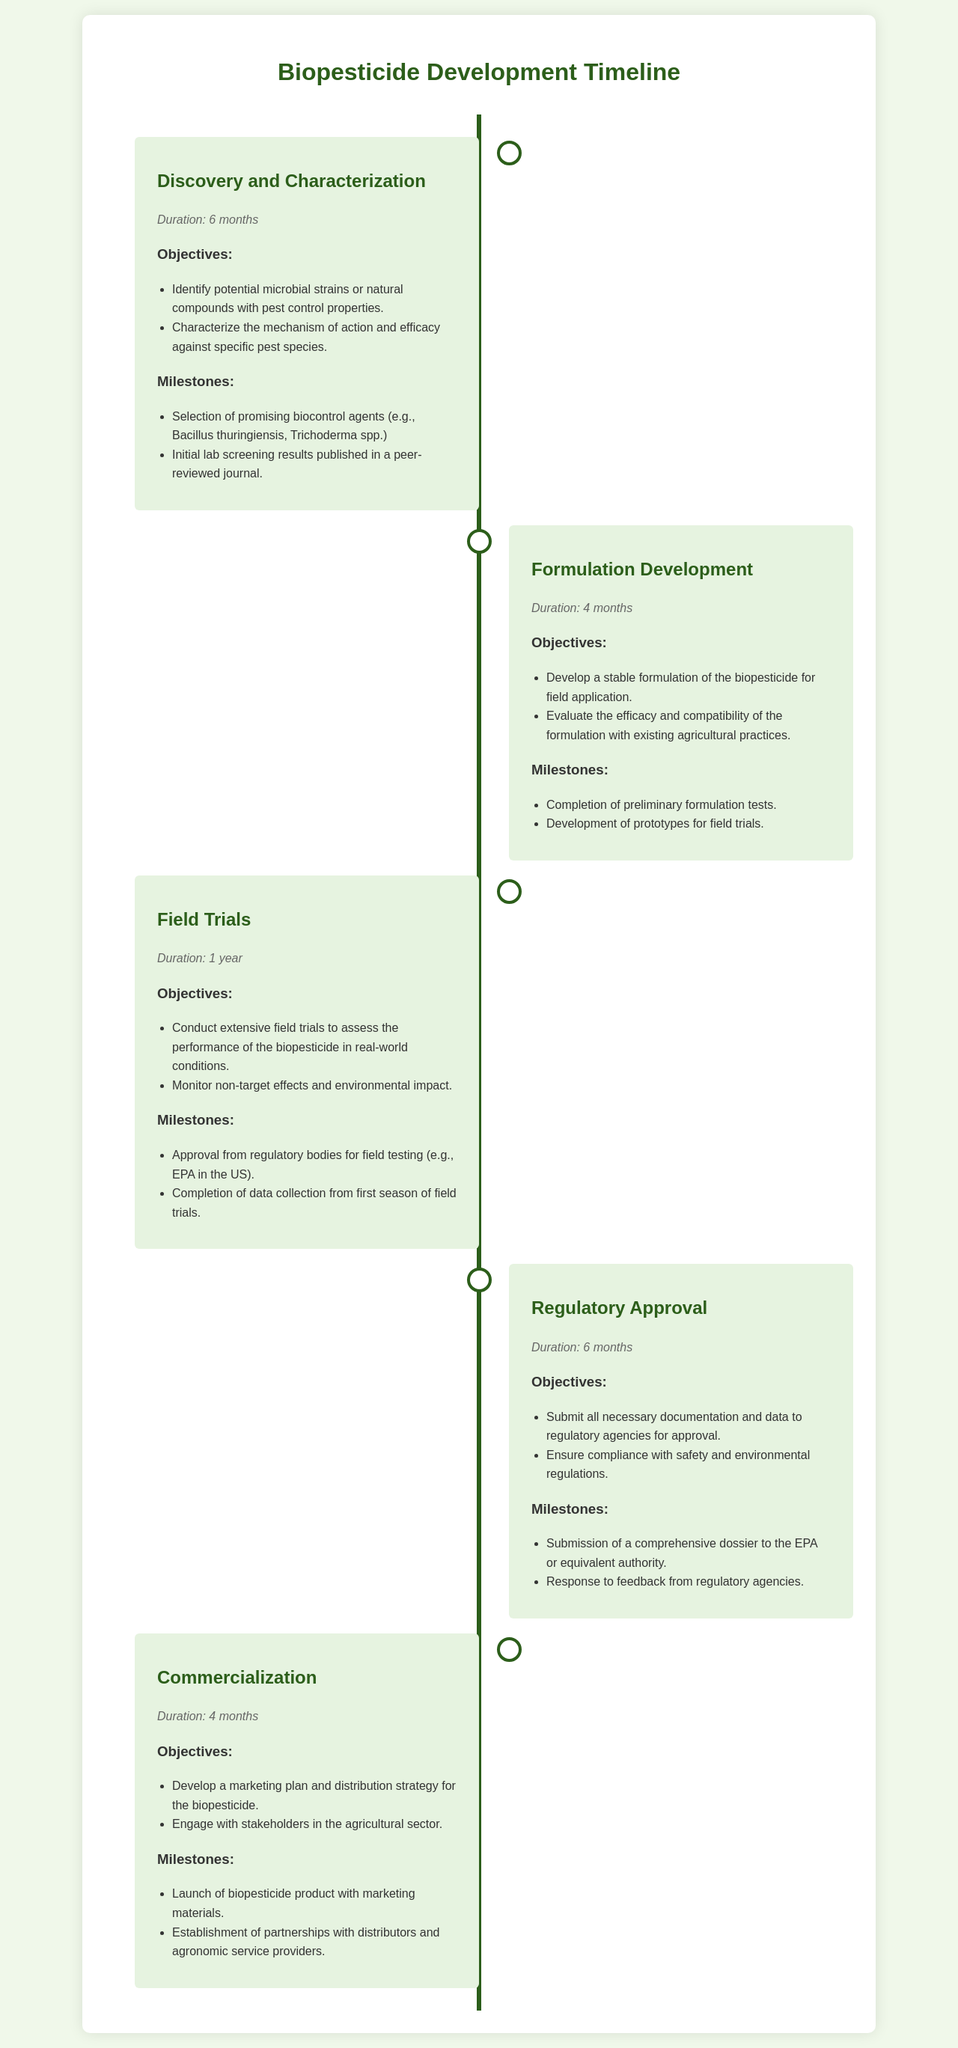What is the duration of the Discovery and Characterization phase? The duration of the Discovery and Characterization phase is specified as 6 months.
Answer: 6 months What is the objective of the Formulation Development phase? The objective of the Formulation Development phase is to develop a stable formulation of the biopesticide for field application and evaluate its efficacy and compatibility.
Answer: Develop a stable formulation What is the milestone associated with Field Trials? One of the milestones in Field Trials is the approval from regulatory bodies for field testing, specifically mentioned as the EPA in the US.
Answer: Approval from regulatory bodies How long is the Regulatory Approval phase? The duration of the Regulatory Approval phase is stated to be 6 months.
Answer: 6 months What is one objective of the Commercialization phase? An objective of the Commercialization phase is to develop a marketing plan and distribution strategy for the biopesticide.
Answer: Develop a marketing plan What is the total duration of the Biopesticide Development process as per the document? To calculate the total duration, add the durations of all phases: 6 months + 4 months + 12 months + 6 months + 4 months = 32 months.
Answer: 32 months What is the key outcome of the Discovery and Characterization phase? A key outcome is the selection of promising biocontrol agents, such as Bacillus thuringiensis and Trichoderma spp.
Answer: Selection of promising biocontrol agents What is required for the completion of the Formulation Development phase? The completion of preliminary formulation tests is required as a milestone in the Formulation Development phase.
Answer: Completion of preliminary formulation tests What type of agents are being selected in the Discovery and Characterization phase? The phase focuses on selecting microbial strains or natural compounds with pest control properties.
Answer: Microbial strains or natural compounds 